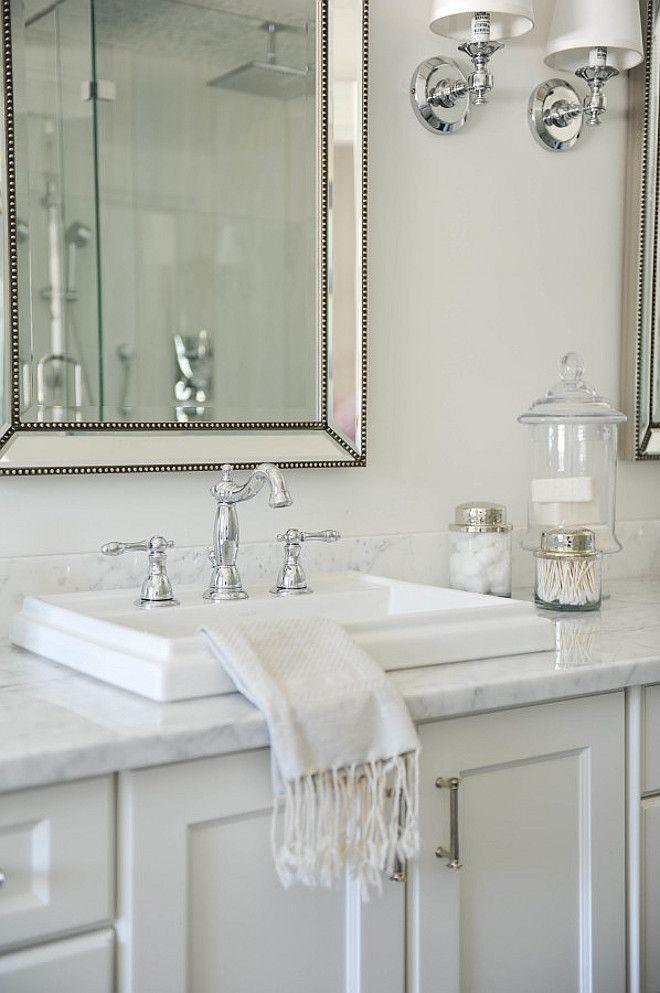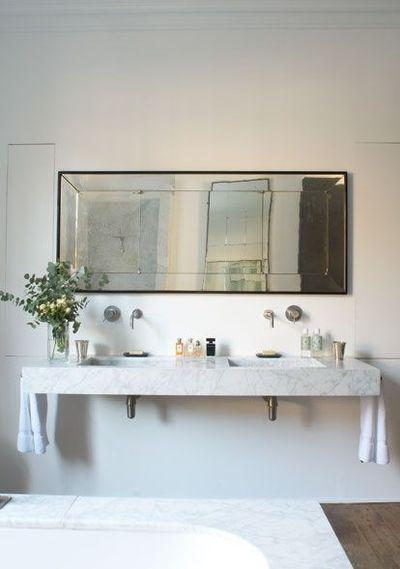The first image is the image on the left, the second image is the image on the right. Considering the images on both sides, is "Both images feature a single-sink vanity." valid? Answer yes or no. No. The first image is the image on the left, the second image is the image on the right. Analyze the images presented: Is the assertion "there is a towel in the image on the left." valid? Answer yes or no. Yes. 